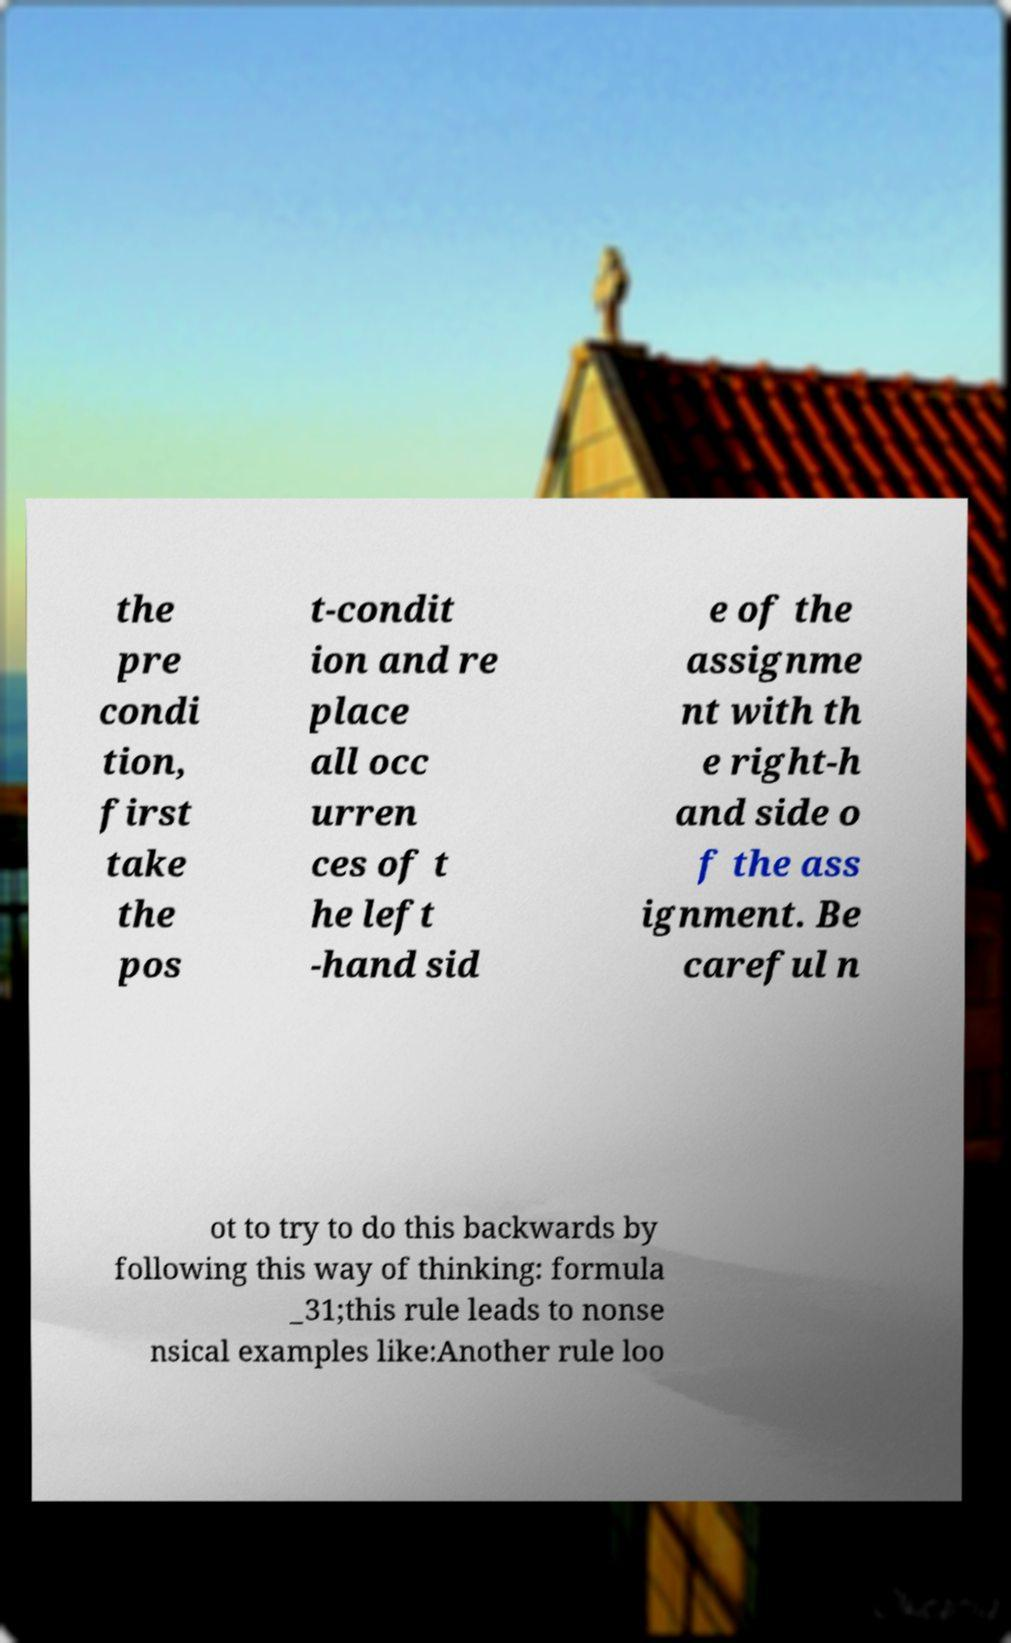Please identify and transcribe the text found in this image. the pre condi tion, first take the pos t-condit ion and re place all occ urren ces of t he left -hand sid e of the assignme nt with th e right-h and side o f the ass ignment. Be careful n ot to try to do this backwards by following this way of thinking: formula _31;this rule leads to nonse nsical examples like:Another rule loo 